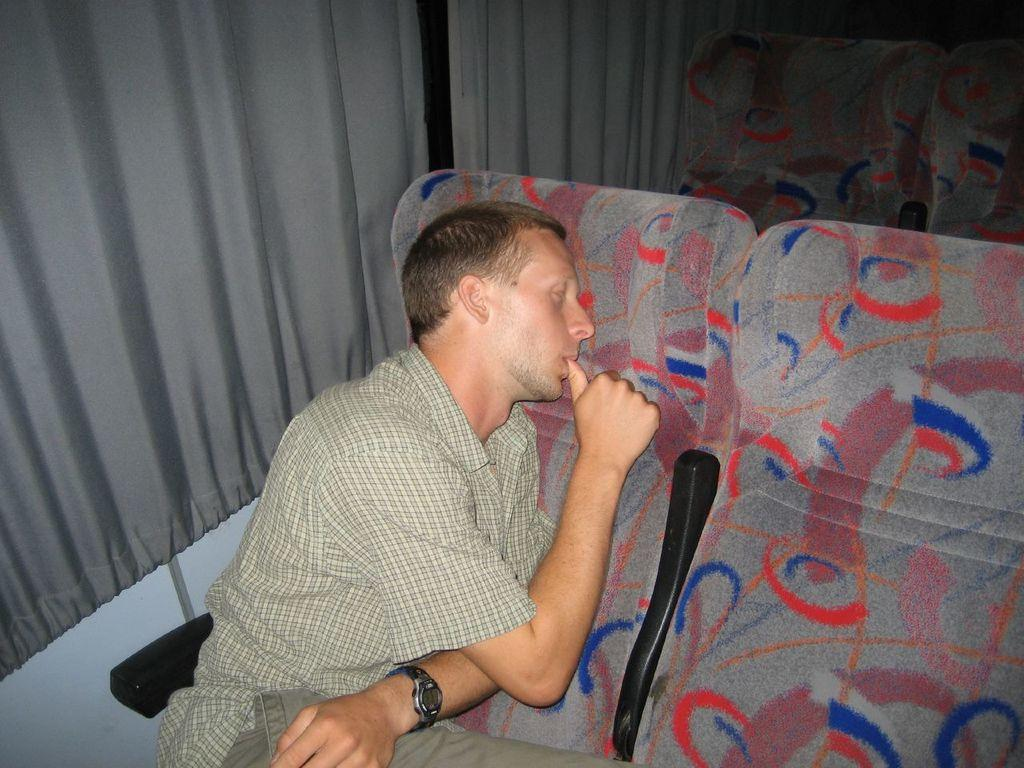What is the person in the image doing? The person is laying on a chair in the image. Can you describe the chairs in the background? There are chairs in the background of the image. What can be seen in the background besides the chairs? There are curtains in the background of the image. What type of guitar is being played in harmony with the yoke in the image? There is no guitar or yoke present in the image. 